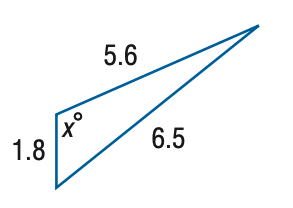Question: Find x. Round the angle measure to the nearest degree.
Choices:
A. 108
B. 112
C. 116
D. 120
Answer with the letter. Answer: B 